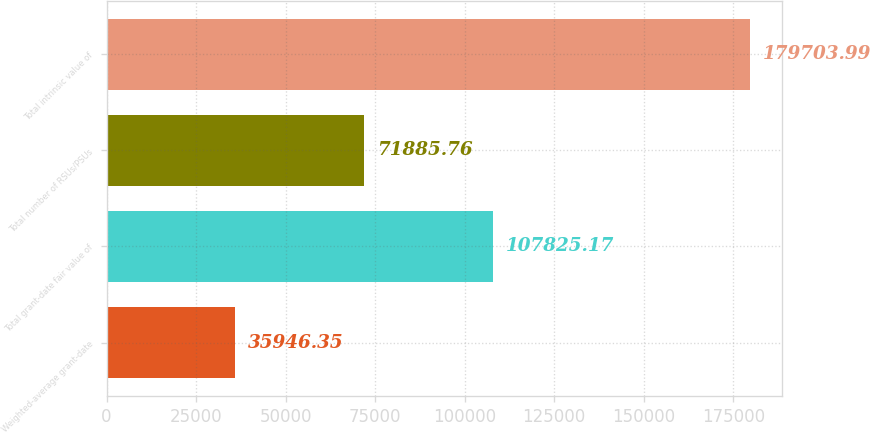Convert chart. <chart><loc_0><loc_0><loc_500><loc_500><bar_chart><fcel>Weighted-average grant-date<fcel>Total grant-date fair value of<fcel>Total number of RSUs/PSUs<fcel>Total intrinsic value of<nl><fcel>35946.3<fcel>107825<fcel>71885.8<fcel>179704<nl></chart> 